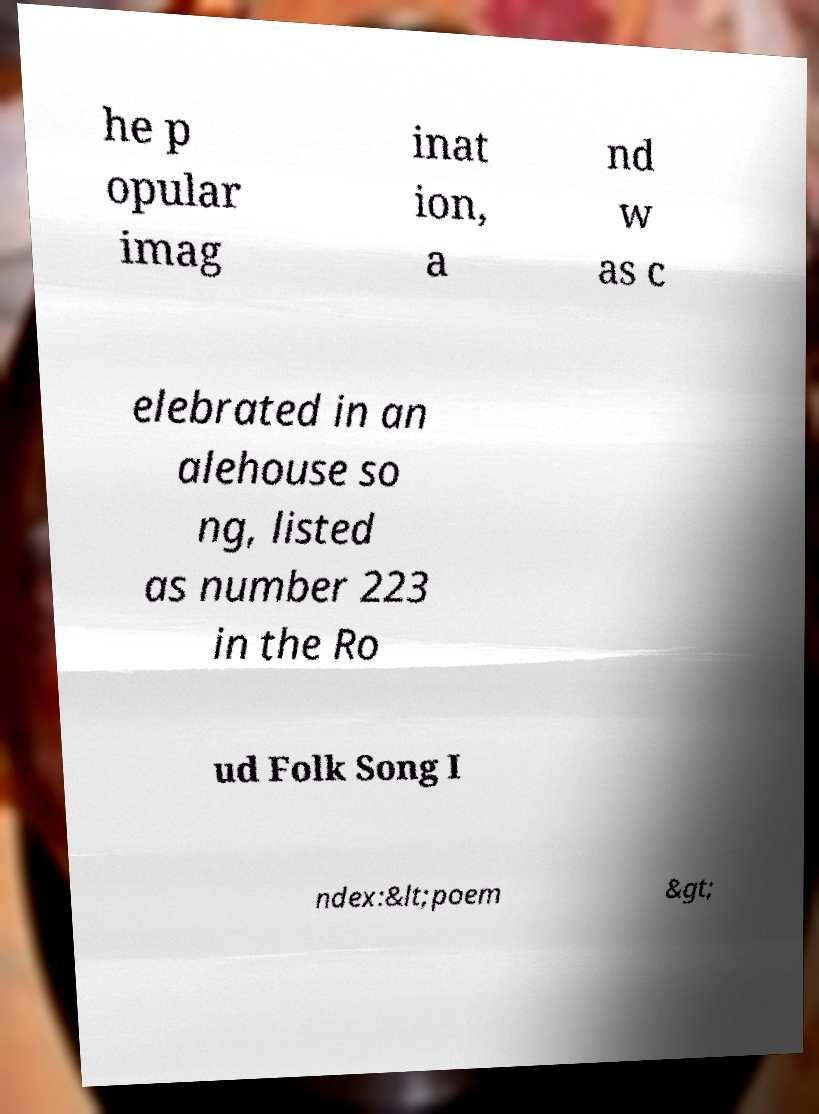What messages or text are displayed in this image? I need them in a readable, typed format. he p opular imag inat ion, a nd w as c elebrated in an alehouse so ng, listed as number 223 in the Ro ud Folk Song I ndex:&lt;poem &gt; 